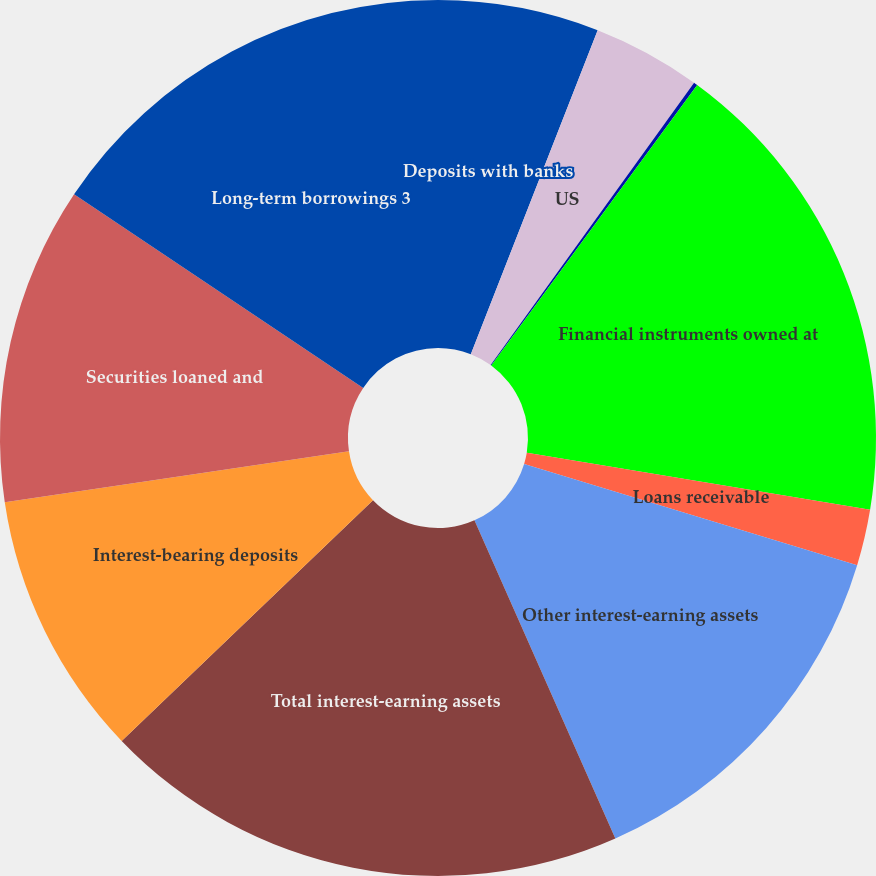Convert chart. <chart><loc_0><loc_0><loc_500><loc_500><pie_chart><fcel>Deposits with banks<fcel>US<fcel>Non-US<fcel>Financial instruments owned at<fcel>Loans receivable<fcel>Other interest-earning assets<fcel>Total interest-earning assets<fcel>Interest-bearing deposits<fcel>Securities loaned and<fcel>Long-term borrowings 3<nl><fcel>5.94%<fcel>4.0%<fcel>0.14%<fcel>17.54%<fcel>2.07%<fcel>13.68%<fcel>19.48%<fcel>9.81%<fcel>11.74%<fcel>15.61%<nl></chart> 